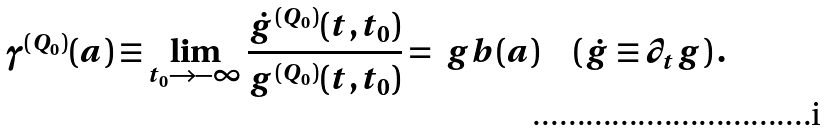Convert formula to latex. <formula><loc_0><loc_0><loc_500><loc_500>\gamma ^ { ( Q _ { 0 } ) } ( a ) \equiv \lim _ { t _ { 0 } \to - \infty } \frac { \dot { g } ^ { ( Q _ { 0 } ) } ( t , t _ { 0 } ) } { g ^ { ( Q _ { 0 } ) } ( t , t _ { 0 } ) } = \ g b ( a ) \quad ( \dot { g } \equiv \partial _ { t } g ) \, .</formula> 